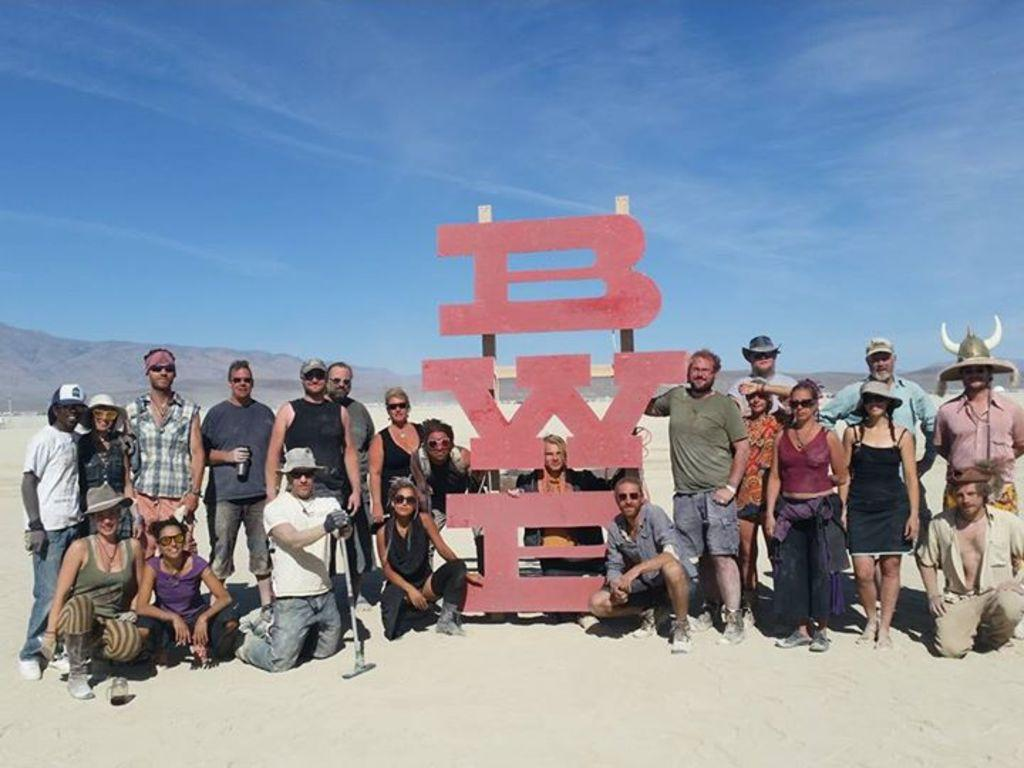What can be seen in the image? There are people standing in the image. What is at the bottom of the image? There is sand at the bottom of the image. What is visible at the top of the image? The sky is visible at the top of the image. What is the man holding in the image? A man is holding something in the image. How many geese are flying in the bubble in the image? There are no bubbles or geese present in the image. What type of respect is shown by the people in the image? The image does not depict any specific type of respect; it simply shows people standing. 